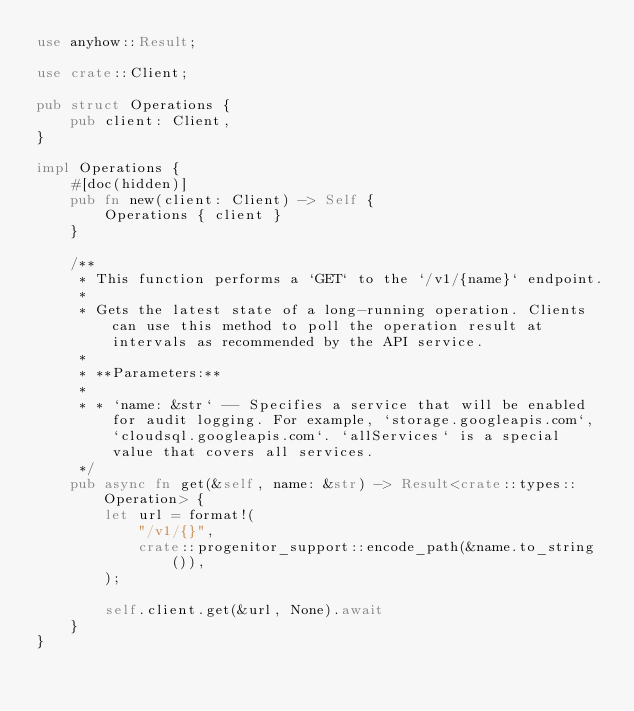Convert code to text. <code><loc_0><loc_0><loc_500><loc_500><_Rust_>use anyhow::Result;

use crate::Client;

pub struct Operations {
    pub client: Client,
}

impl Operations {
    #[doc(hidden)]
    pub fn new(client: Client) -> Self {
        Operations { client }
    }

    /**
     * This function performs a `GET` to the `/v1/{name}` endpoint.
     *
     * Gets the latest state of a long-running operation. Clients can use this method to poll the operation result at intervals as recommended by the API service.
     *
     * **Parameters:**
     *
     * * `name: &str` -- Specifies a service that will be enabled for audit logging. For example, `storage.googleapis.com`, `cloudsql.googleapis.com`. `allServices` is a special value that covers all services.
     */
    pub async fn get(&self, name: &str) -> Result<crate::types::Operation> {
        let url = format!(
            "/v1/{}",
            crate::progenitor_support::encode_path(&name.to_string()),
        );

        self.client.get(&url, None).await
    }
}
</code> 